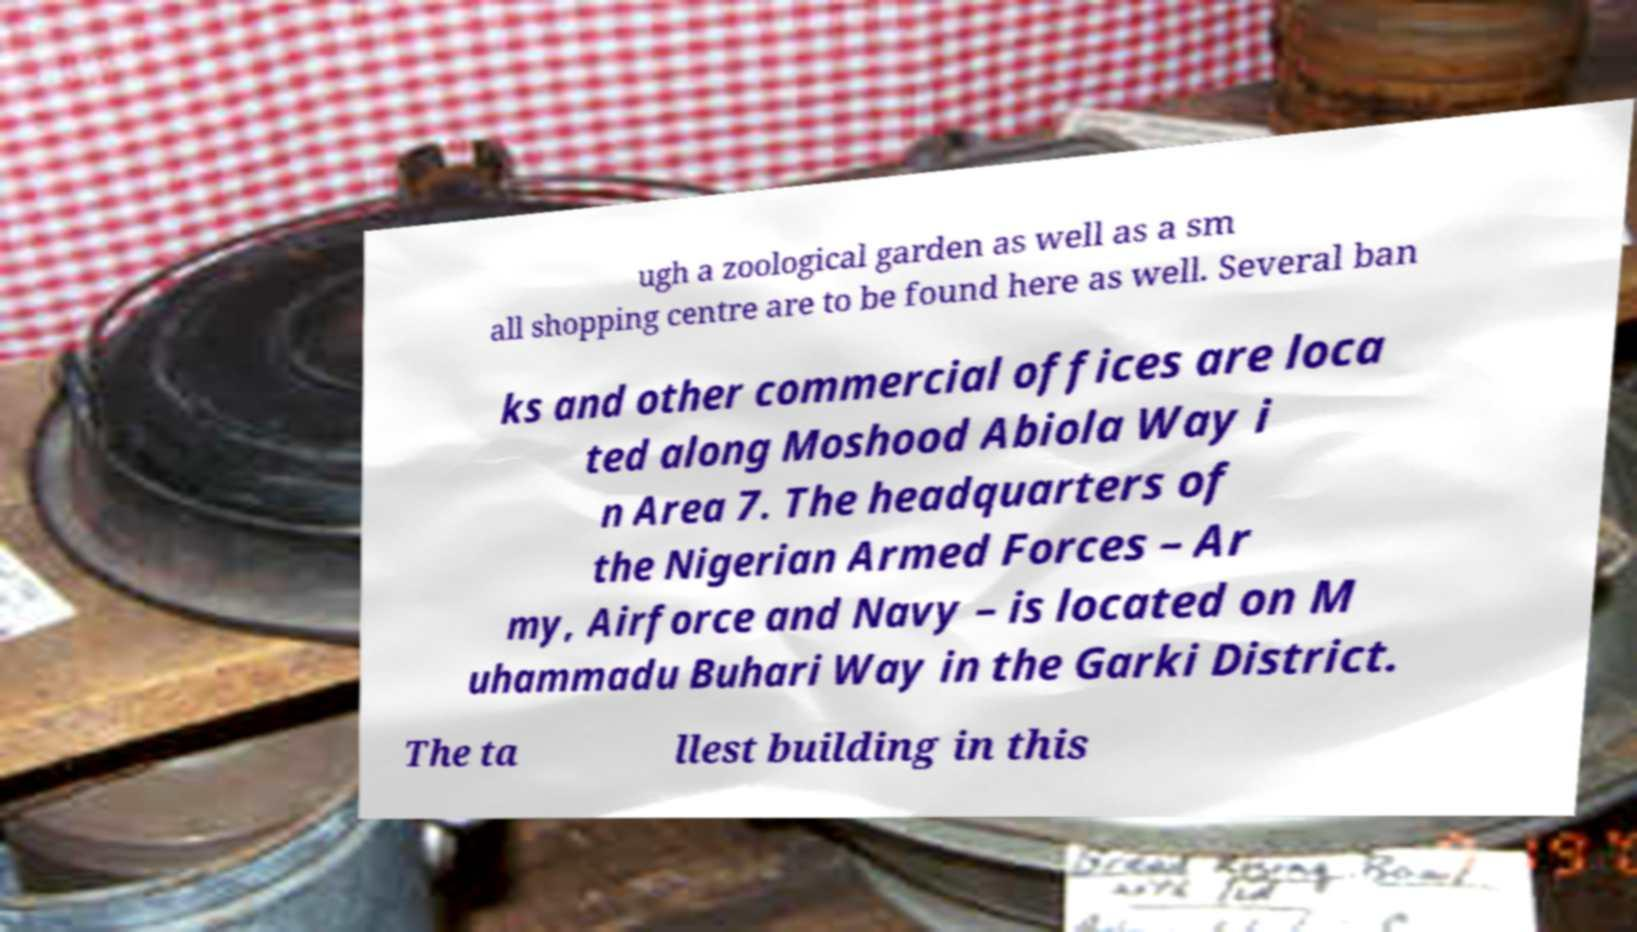Could you assist in decoding the text presented in this image and type it out clearly? ugh a zoological garden as well as a sm all shopping centre are to be found here as well. Several ban ks and other commercial offices are loca ted along Moshood Abiola Way i n Area 7. The headquarters of the Nigerian Armed Forces – Ar my, Airforce and Navy – is located on M uhammadu Buhari Way in the Garki District. The ta llest building in this 